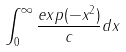<formula> <loc_0><loc_0><loc_500><loc_500>\int _ { 0 } ^ { \infty } \frac { e x p ( - x ^ { 2 } ) } { c } d x</formula> 